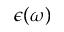Convert formula to latex. <formula><loc_0><loc_0><loc_500><loc_500>\epsilon ( \omega )</formula> 